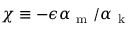<formula> <loc_0><loc_0><loc_500><loc_500>\chi \equiv - \epsilon \alpha _ { m } / \alpha _ { k }</formula> 